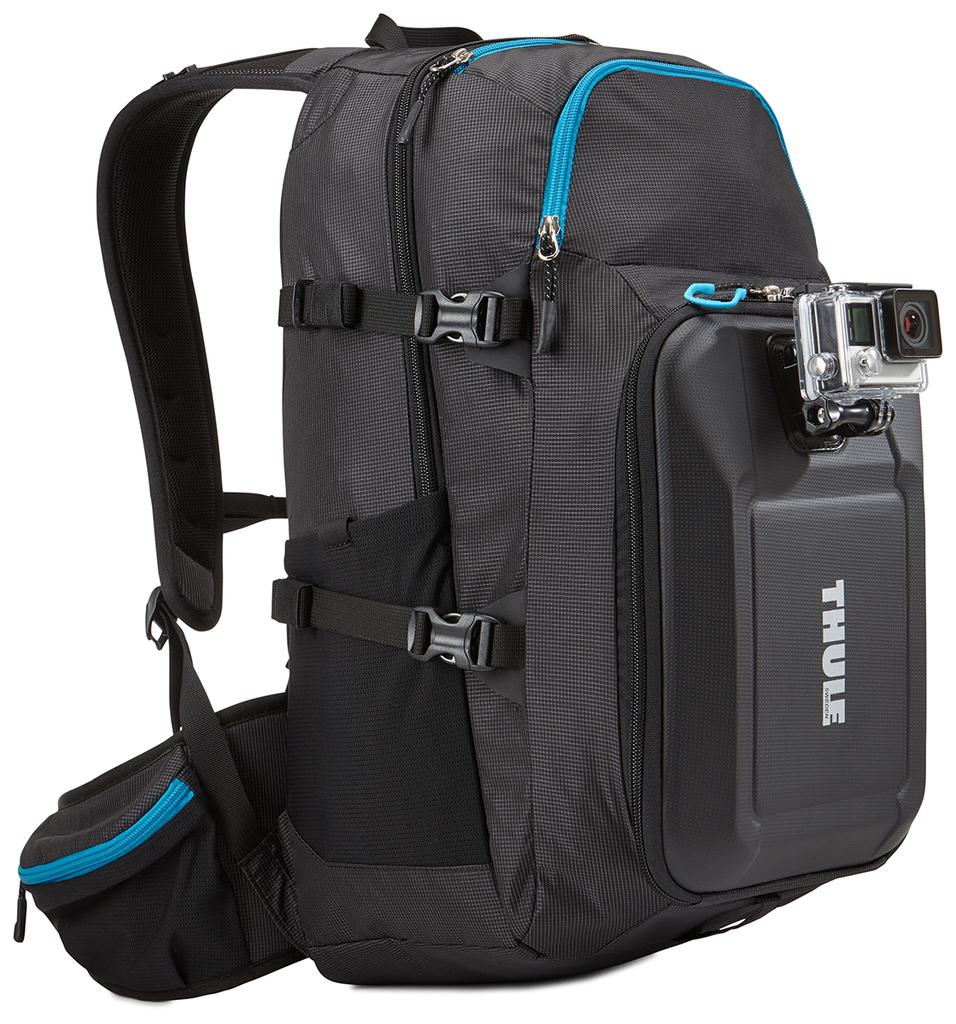What object can be seen in the image? There is a bag in the image. What color is the bag? The bag is black in color. Is there any equipment attached to the bag? Yes, there is a camera attached to the bag. Is there a battle taking place in the image? No, there is no battle present in the image. Can you see the person's uncle in the image? There is no person or uncle mentioned in the provided facts, so it cannot be determined from the image. 